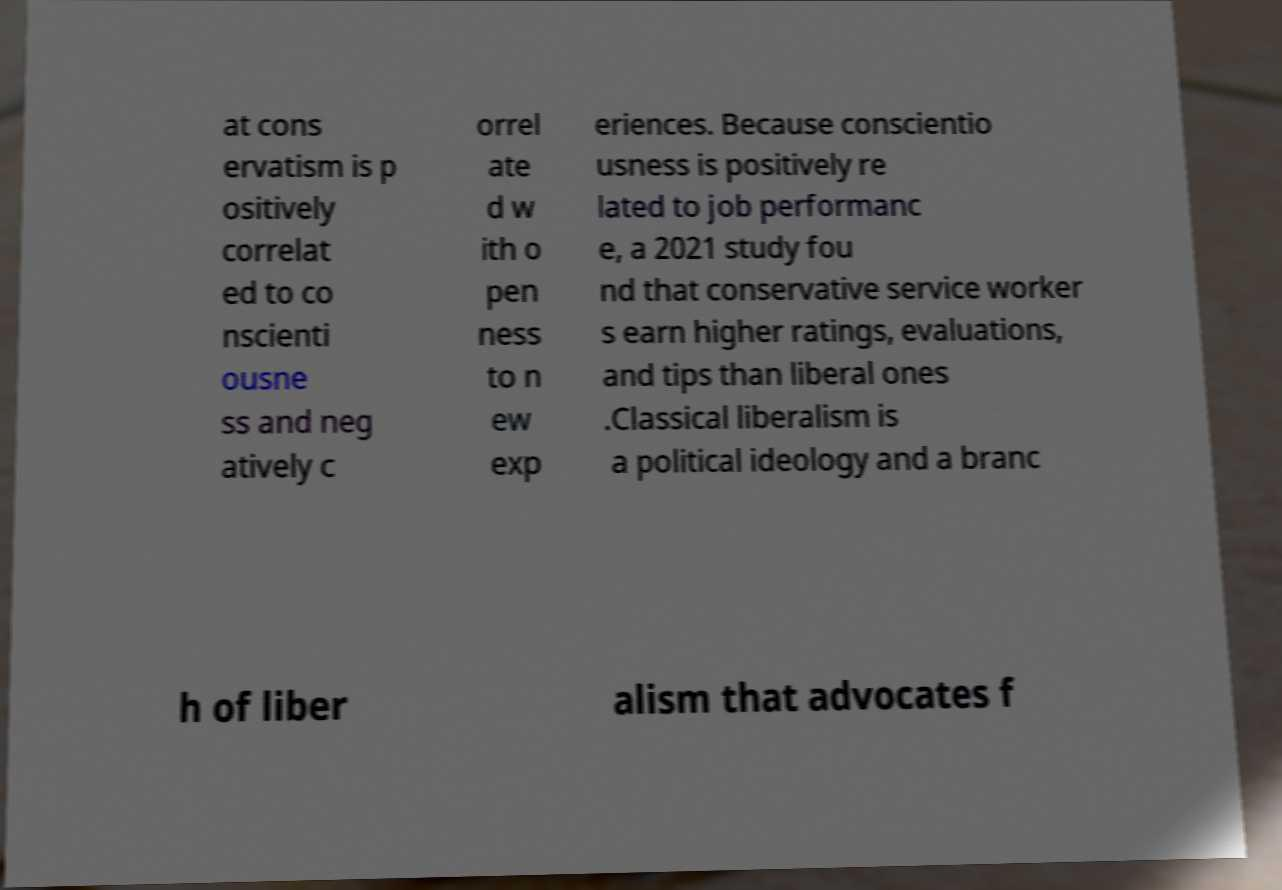Please read and relay the text visible in this image. What does it say? at cons ervatism is p ositively correlat ed to co nscienti ousne ss and neg atively c orrel ate d w ith o pen ness to n ew exp eriences. Because conscientio usness is positively re lated to job performanc e, a 2021 study fou nd that conservative service worker s earn higher ratings, evaluations, and tips than liberal ones .Classical liberalism is a political ideology and a branc h of liber alism that advocates f 